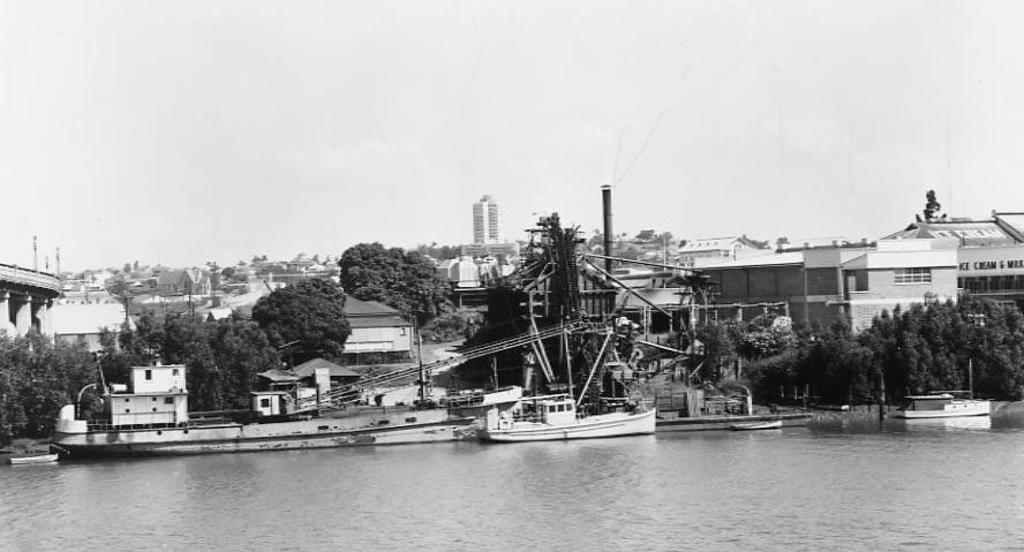In one or two sentences, can you explain what this image depicts? This is a black and white image. In the image we can see there are boats in the water. There are even trees and buildings and a sky. 